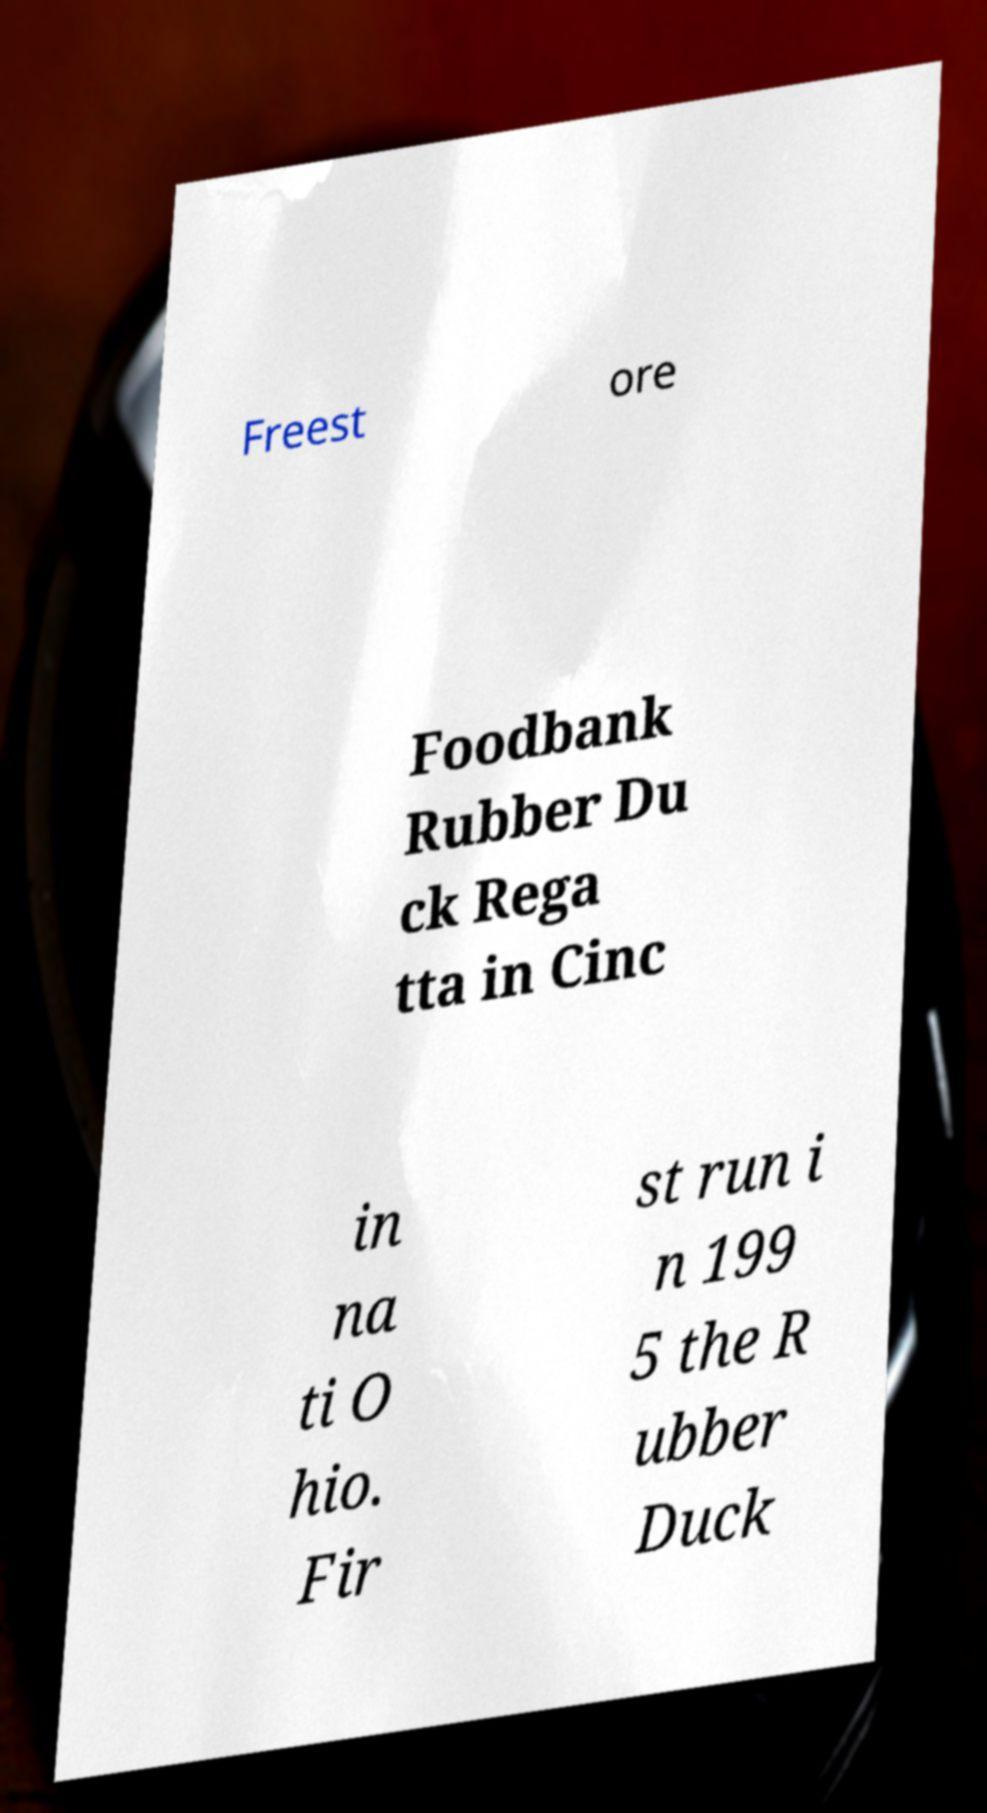Can you read and provide the text displayed in the image?This photo seems to have some interesting text. Can you extract and type it out for me? Freest ore Foodbank Rubber Du ck Rega tta in Cinc in na ti O hio. Fir st run i n 199 5 the R ubber Duck 